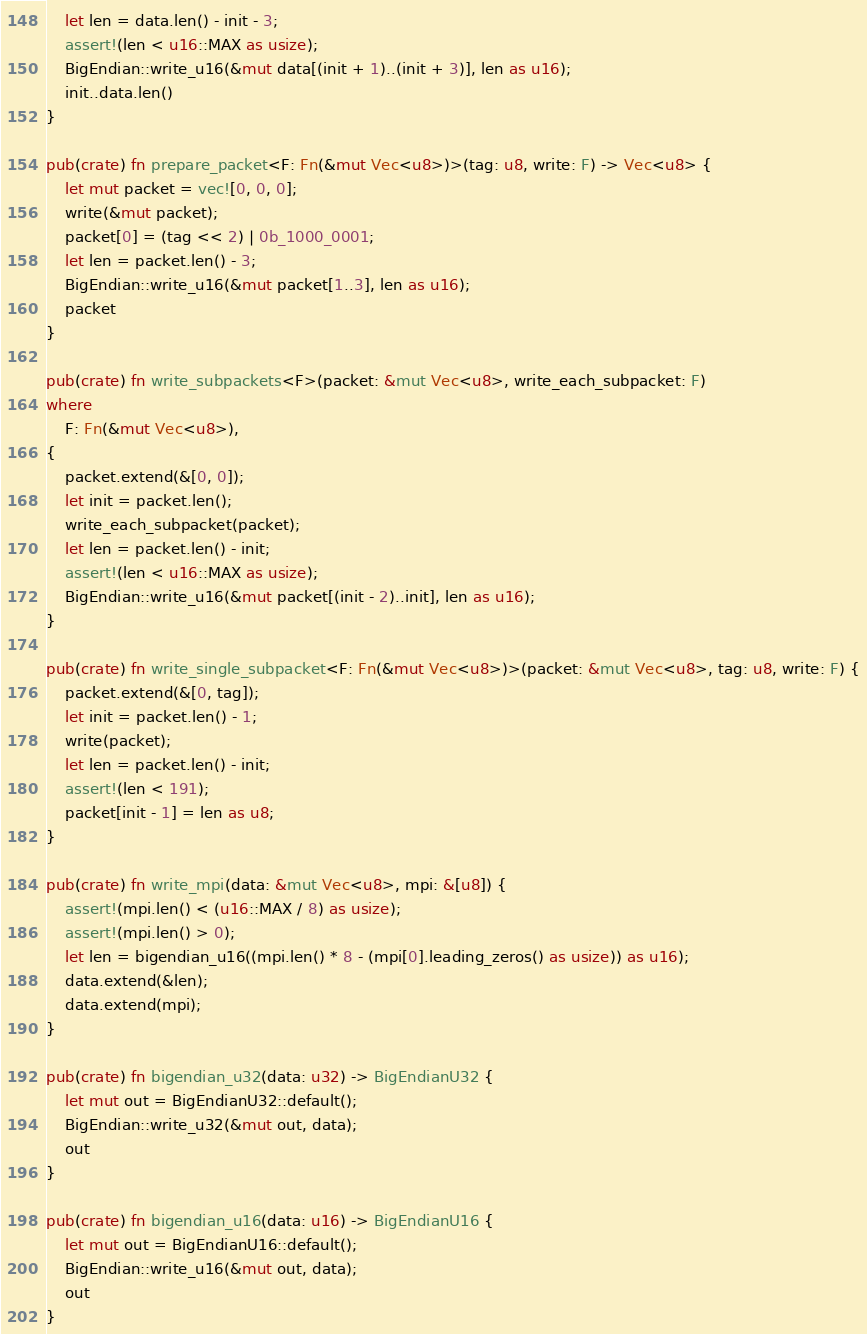<code> <loc_0><loc_0><loc_500><loc_500><_Rust_>    let len = data.len() - init - 3;
    assert!(len < u16::MAX as usize);
    BigEndian::write_u16(&mut data[(init + 1)..(init + 3)], len as u16);
    init..data.len()
}

pub(crate) fn prepare_packet<F: Fn(&mut Vec<u8>)>(tag: u8, write: F) -> Vec<u8> {
    let mut packet = vec![0, 0, 0];
    write(&mut packet);
    packet[0] = (tag << 2) | 0b_1000_0001;
    let len = packet.len() - 3;
    BigEndian::write_u16(&mut packet[1..3], len as u16);
    packet
}

pub(crate) fn write_subpackets<F>(packet: &mut Vec<u8>, write_each_subpacket: F)
where
    F: Fn(&mut Vec<u8>),
{
    packet.extend(&[0, 0]);
    let init = packet.len();
    write_each_subpacket(packet);
    let len = packet.len() - init;
    assert!(len < u16::MAX as usize);
    BigEndian::write_u16(&mut packet[(init - 2)..init], len as u16);
}

pub(crate) fn write_single_subpacket<F: Fn(&mut Vec<u8>)>(packet: &mut Vec<u8>, tag: u8, write: F) {
    packet.extend(&[0, tag]);
    let init = packet.len() - 1;
    write(packet);
    let len = packet.len() - init;
    assert!(len < 191);
    packet[init - 1] = len as u8;
}

pub(crate) fn write_mpi(data: &mut Vec<u8>, mpi: &[u8]) {
    assert!(mpi.len() < (u16::MAX / 8) as usize);
    assert!(mpi.len() > 0);
    let len = bigendian_u16((mpi.len() * 8 - (mpi[0].leading_zeros() as usize)) as u16);
    data.extend(&len);
    data.extend(mpi);
}

pub(crate) fn bigendian_u32(data: u32) -> BigEndianU32 {
    let mut out = BigEndianU32::default();
    BigEndian::write_u32(&mut out, data);
    out
}

pub(crate) fn bigendian_u16(data: u16) -> BigEndianU16 {
    let mut out = BigEndianU16::default();
    BigEndian::write_u16(&mut out, data);
    out
}
</code> 